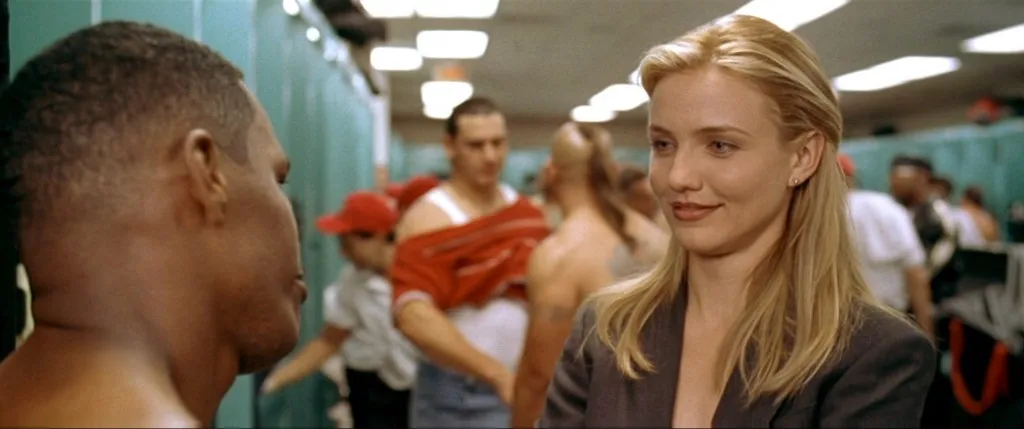Describe the emotions conveyed by the individuals in the foreground. The woman's expression is composed but intent, suggesting a serious but controlled demeanor. The man's gaze is direct and focused, which might indicate concern or determination, perhaps in response to what the woman is saying. 